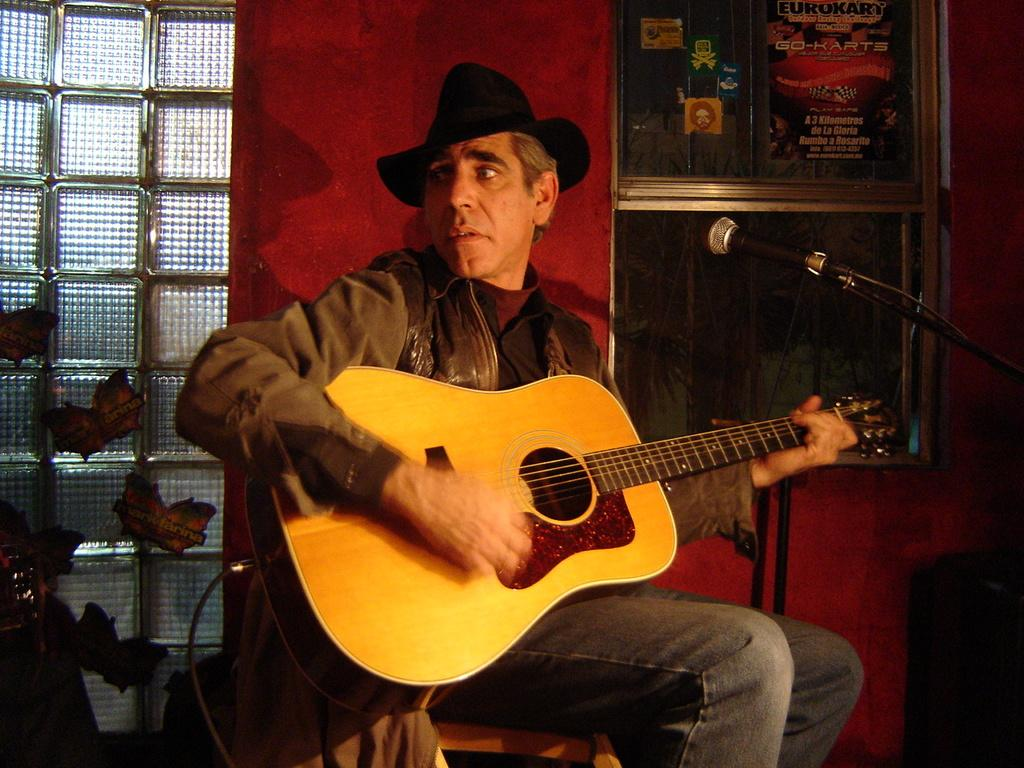What is the person in the image doing? The person is sitting and playing the guitar. What is the person wearing on their head? The person is wearing a hat. What object is the person holding while playing the guitar? The person is holding a guitar. What is in front of the person while they are playing the guitar? There is a microphone in front of the person. What can be seen in the background of the image? There is a red wall, a window, and photo frames in the background. Can you tell me how many dogs are sitting next to the person playing the guitar in the image? There are no dogs present in the image. What type of thrill can be experienced by the person playing the guitar in the image? The image does not convey any specific emotions or experiences, so it is not possible to determine the type of thrill the person might be experiencing. 